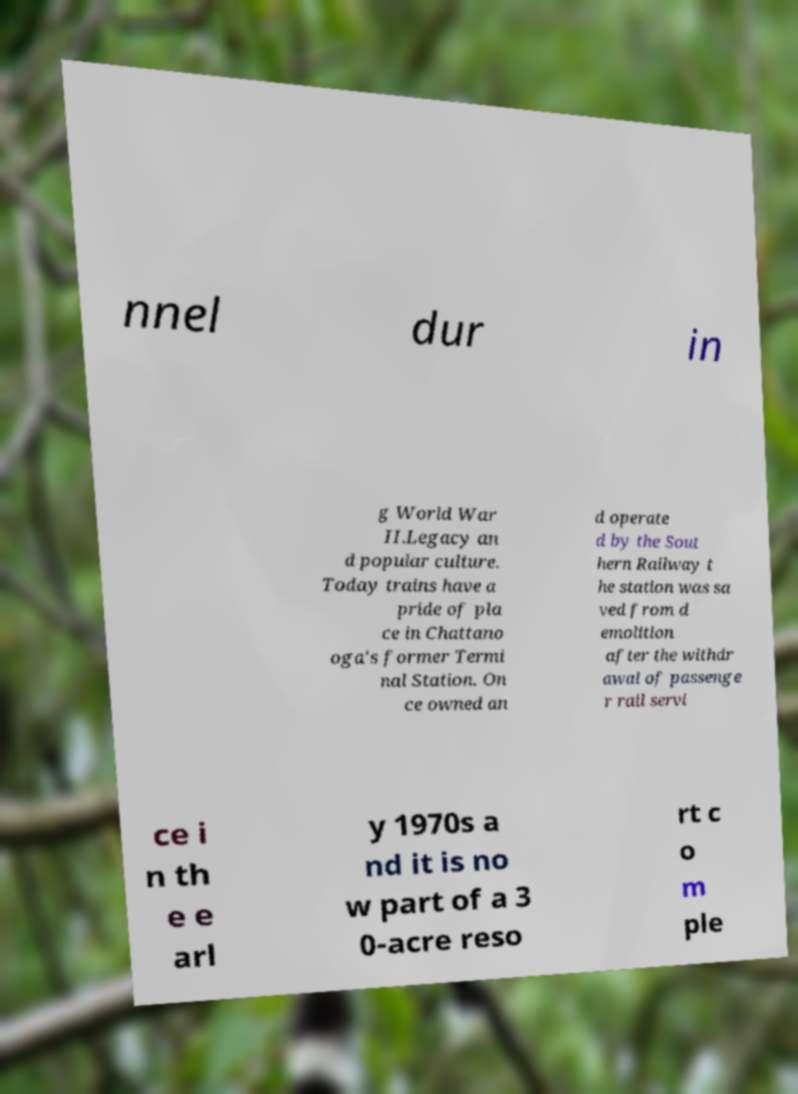Can you read and provide the text displayed in the image?This photo seems to have some interesting text. Can you extract and type it out for me? nnel dur in g World War II.Legacy an d popular culture. Today trains have a pride of pla ce in Chattano oga's former Termi nal Station. On ce owned an d operate d by the Sout hern Railway t he station was sa ved from d emolition after the withdr awal of passenge r rail servi ce i n th e e arl y 1970s a nd it is no w part of a 3 0-acre reso rt c o m ple 